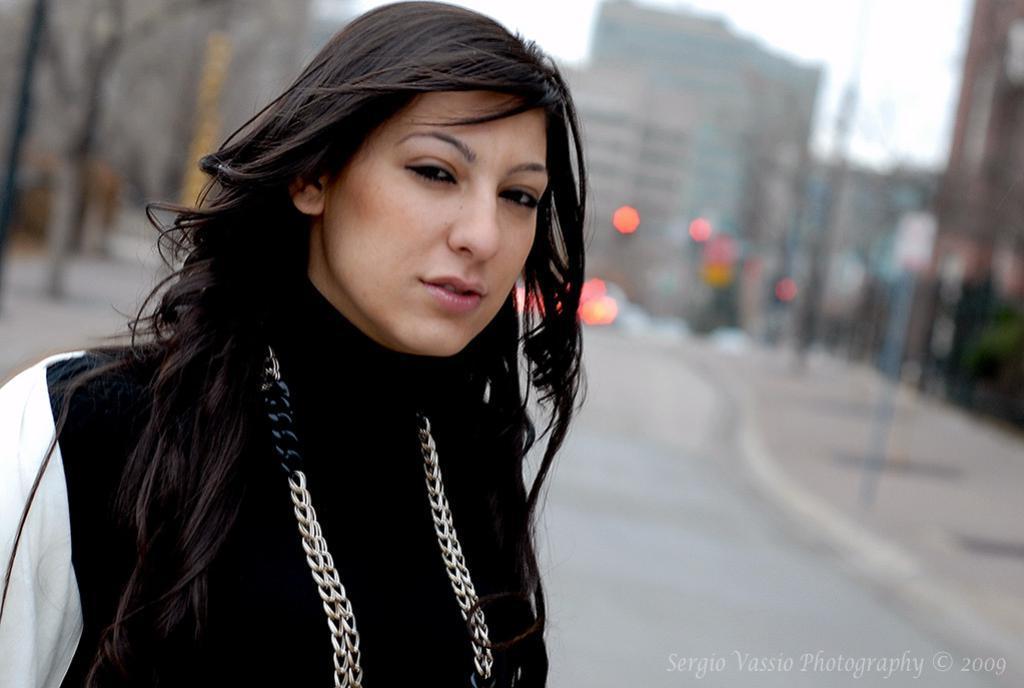Could you give a brief overview of what you see in this image? In this image I see a woman who is wearing a black and white top and In the background I see lot of buildings which are blurred and also the road. 